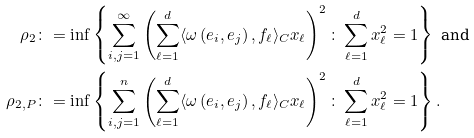<formula> <loc_0><loc_0><loc_500><loc_500>\rho _ { 2 } & \colon = \inf \left \{ \sum _ { i , j = 1 } ^ { \infty } \left ( \sum _ { \ell = 1 } ^ { d } \langle \omega \left ( e _ { i } , e _ { j } \right ) , f _ { \ell } \rangle _ { C } x _ { \ell } \right ) ^ { 2 } \colon \sum _ { \ell = 1 } ^ { d } x _ { \ell } ^ { 2 } = 1 \right \} \text { and } \\ \rho _ { 2 , P } & \colon = \inf \left \{ \sum _ { i , j = 1 } ^ { n } \left ( \sum _ { \ell = 1 } ^ { d } \langle \omega \left ( e _ { i } , e _ { j } \right ) , f _ { \ell } \rangle _ { C } x _ { \ell } \right ) ^ { 2 } \colon \sum _ { \ell = 1 } ^ { d } x _ { \ell } ^ { 2 } = 1 \right \} .</formula> 